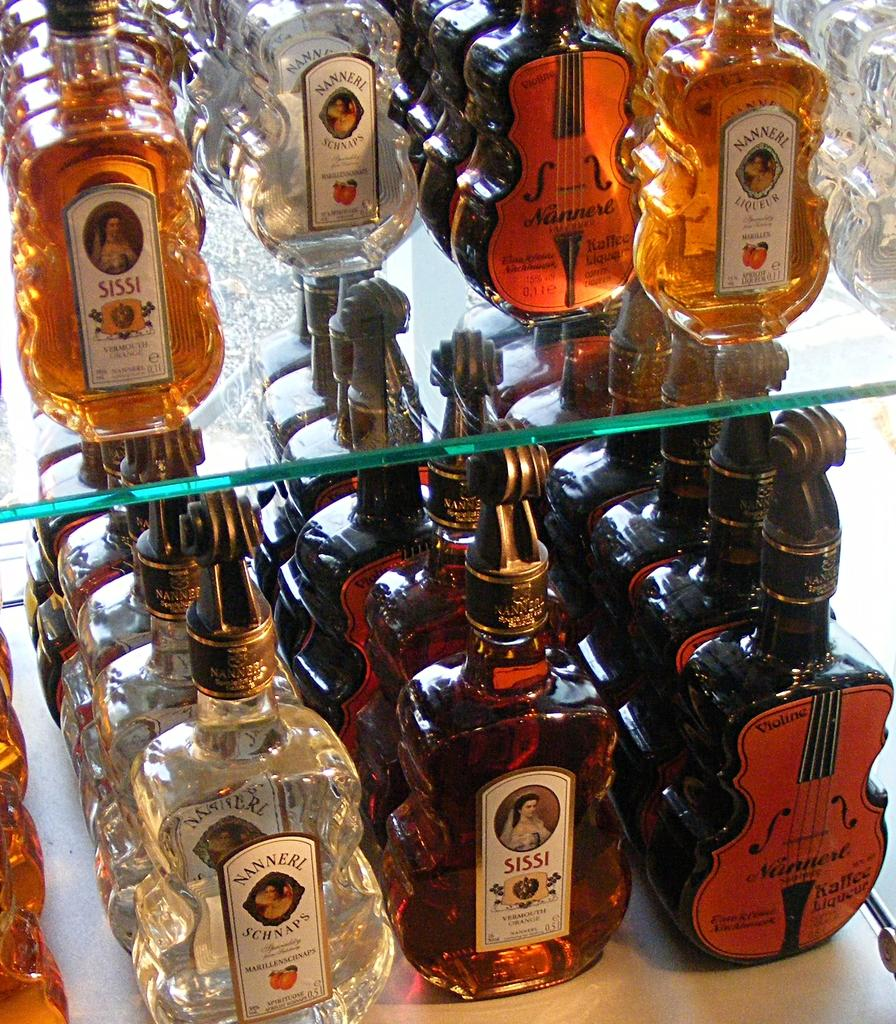<image>
Render a clear and concise summary of the photo. two shelves of bottles with some labeled as 'nanneri schnaps' 